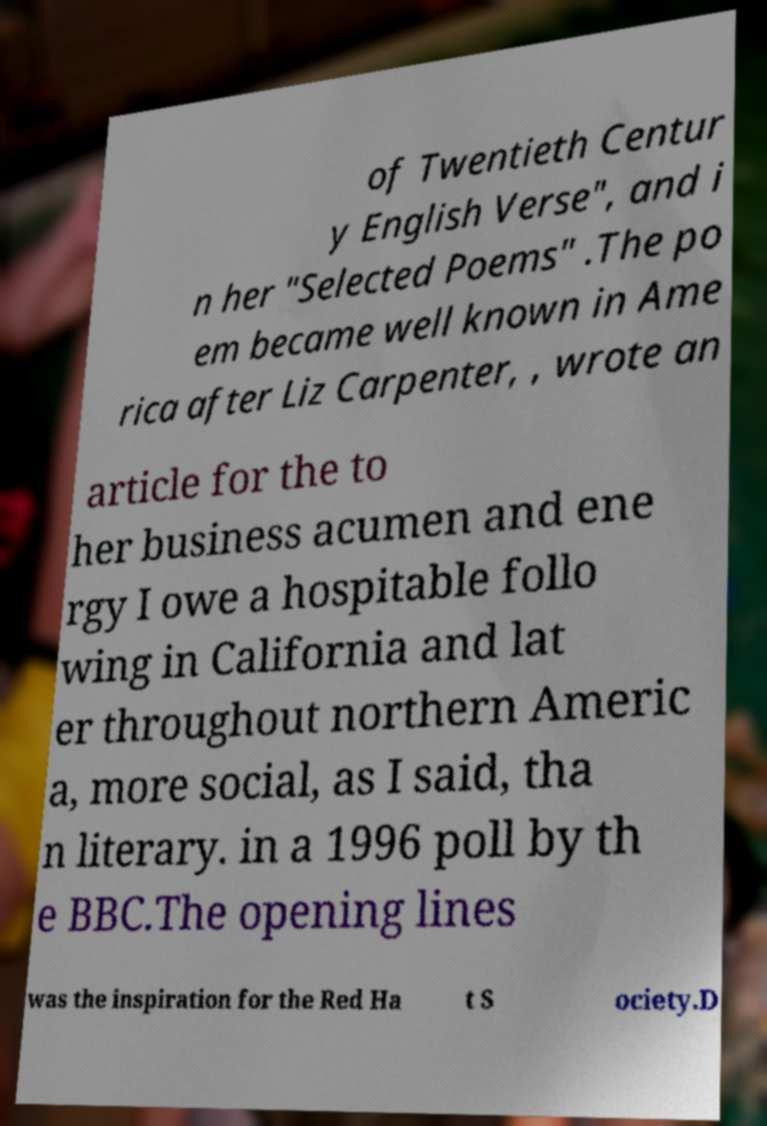Please identify and transcribe the text found in this image. of Twentieth Centur y English Verse", and i n her "Selected Poems" .The po em became well known in Ame rica after Liz Carpenter, , wrote an article for the to her business acumen and ene rgy I owe a hospitable follo wing in California and lat er throughout northern Americ a, more social, as I said, tha n literary. in a 1996 poll by th e BBC.The opening lines was the inspiration for the Red Ha t S ociety.D 